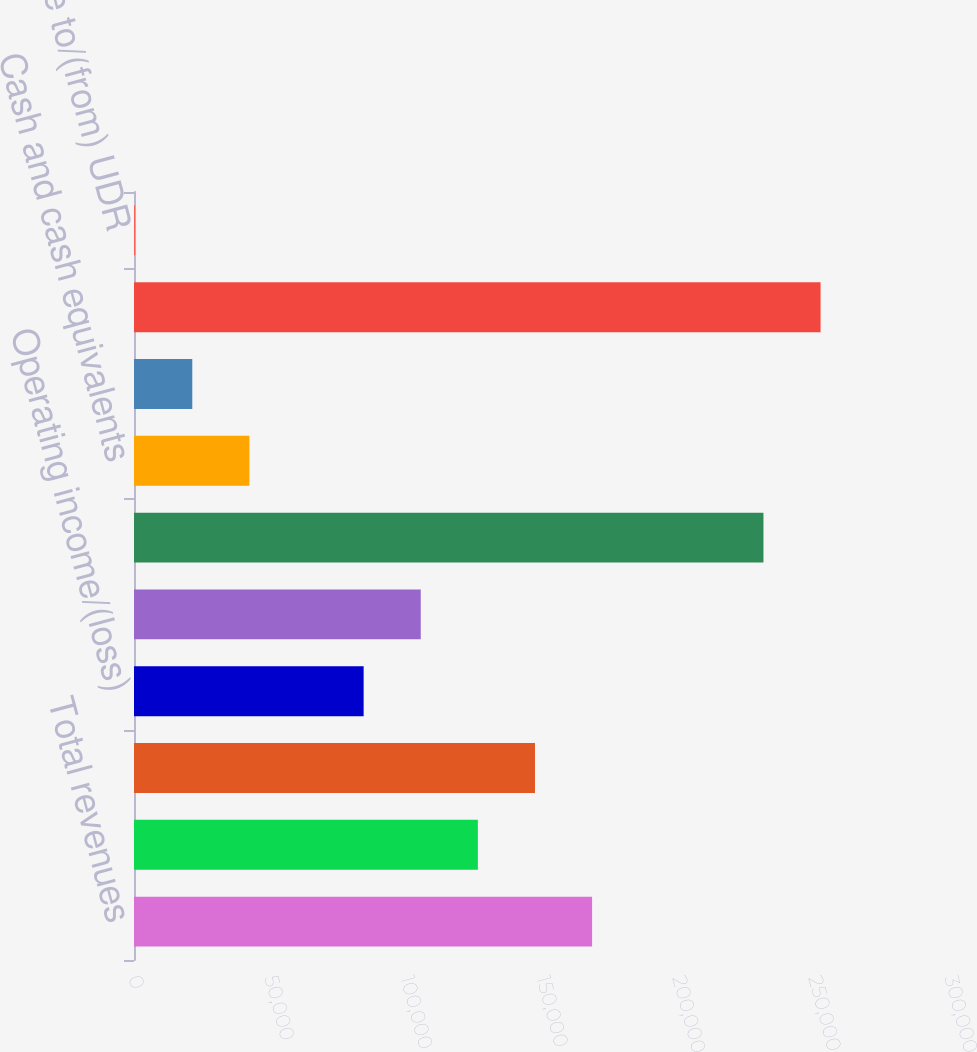Convert chart to OTSL. <chart><loc_0><loc_0><loc_500><loc_500><bar_chart><fcel>Total revenues<fcel>Property operating expenses<fcel>Real estate depreciation and<fcel>Operating income/(loss)<fcel>Net income/(loss)<fcel>Total real estate net<fcel>Cash and cash equivalents<fcel>Other assets<fcel>Total assets<fcel>Amount due to/(from) UDR<nl><fcel>168421<fcel>126423<fcel>147422<fcel>84425<fcel>105424<fcel>231418<fcel>42427<fcel>21428<fcel>252417<fcel>429<nl></chart> 